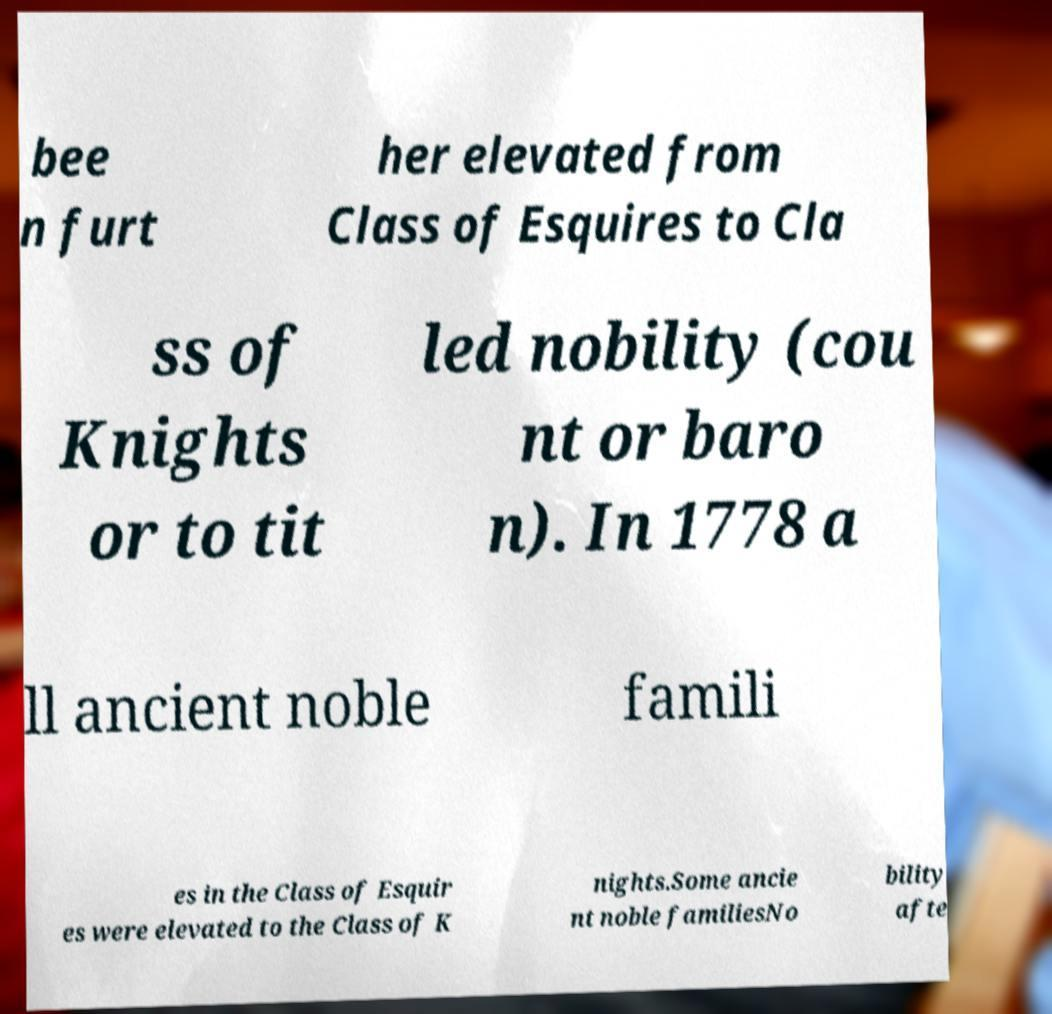Can you read and provide the text displayed in the image?This photo seems to have some interesting text. Can you extract and type it out for me? bee n furt her elevated from Class of Esquires to Cla ss of Knights or to tit led nobility (cou nt or baro n). In 1778 a ll ancient noble famili es in the Class of Esquir es were elevated to the Class of K nights.Some ancie nt noble familiesNo bility afte 